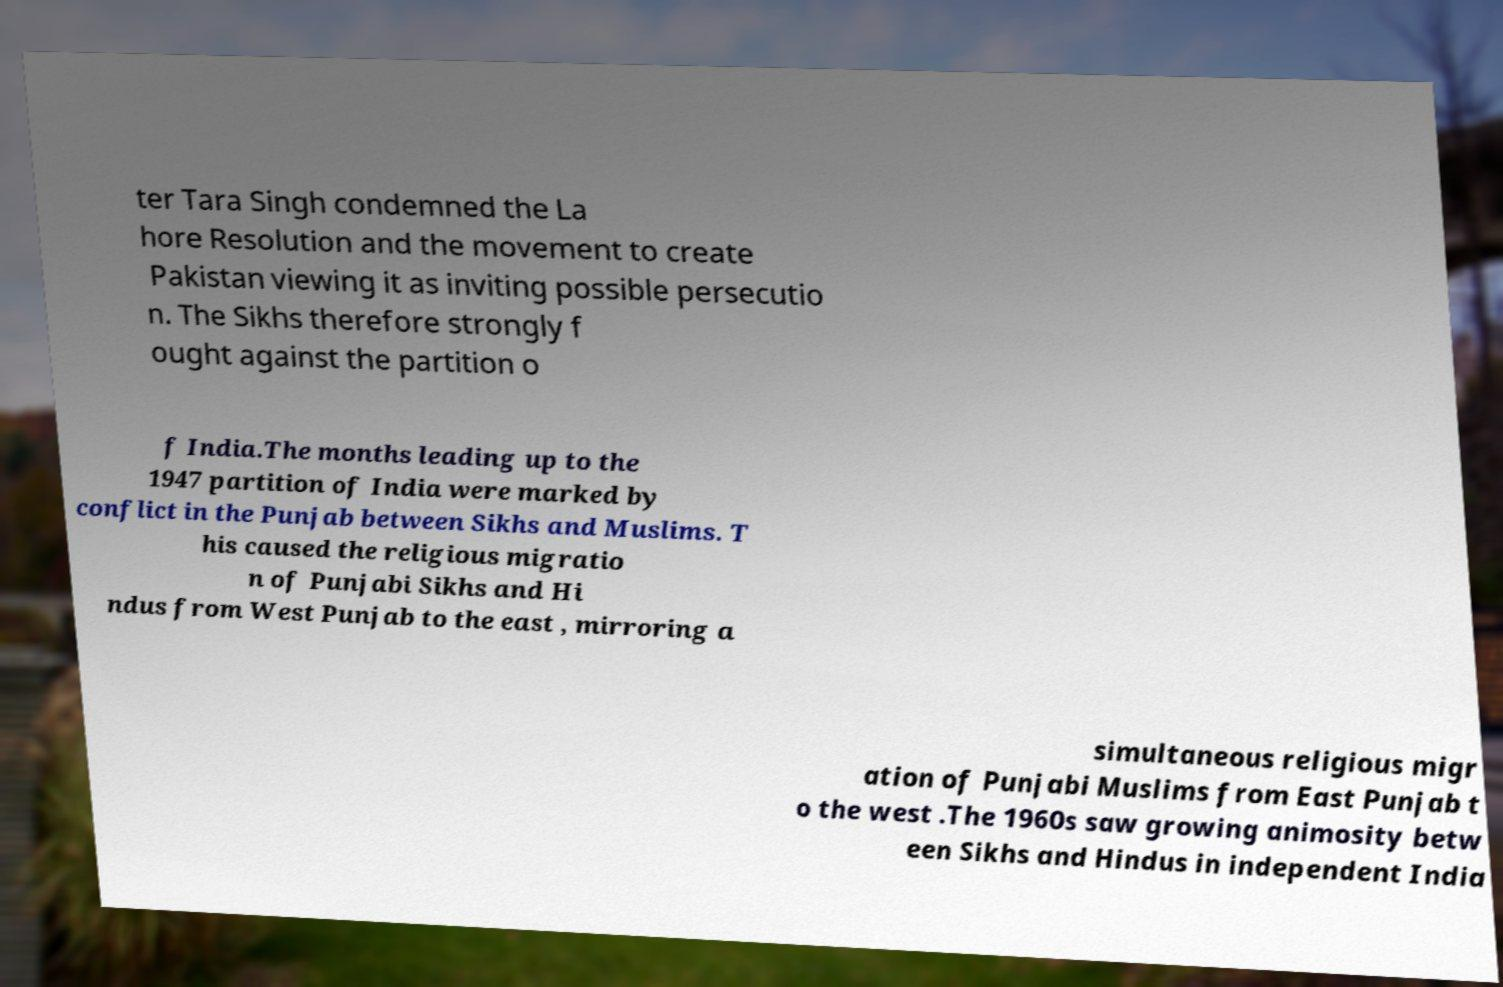Can you accurately transcribe the text from the provided image for me? ter Tara Singh condemned the La hore Resolution and the movement to create Pakistan viewing it as inviting possible persecutio n. The Sikhs therefore strongly f ought against the partition o f India.The months leading up to the 1947 partition of India were marked by conflict in the Punjab between Sikhs and Muslims. T his caused the religious migratio n of Punjabi Sikhs and Hi ndus from West Punjab to the east , mirroring a simultaneous religious migr ation of Punjabi Muslims from East Punjab t o the west .The 1960s saw growing animosity betw een Sikhs and Hindus in independent India 